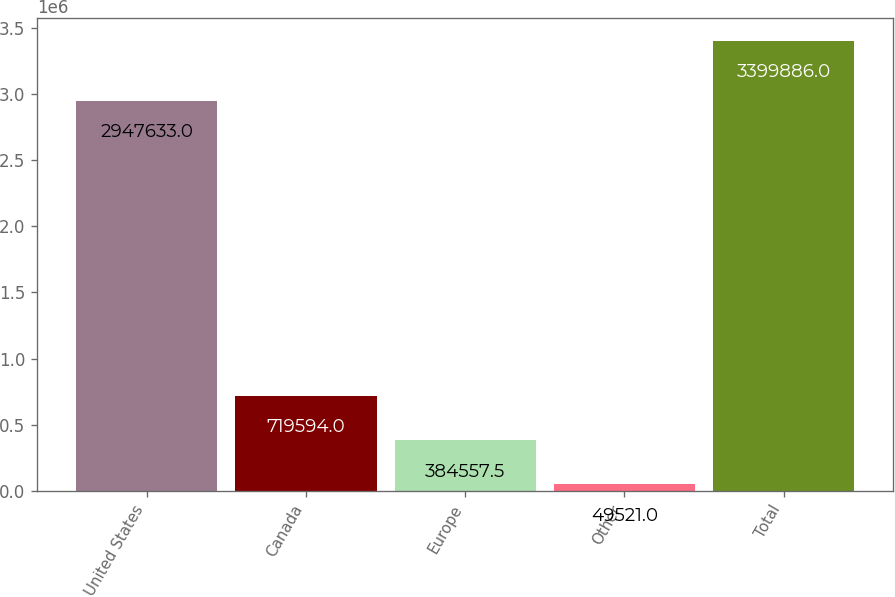Convert chart. <chart><loc_0><loc_0><loc_500><loc_500><bar_chart><fcel>United States<fcel>Canada<fcel>Europe<fcel>Other<fcel>Total<nl><fcel>2.94763e+06<fcel>719594<fcel>384558<fcel>49521<fcel>3.39989e+06<nl></chart> 